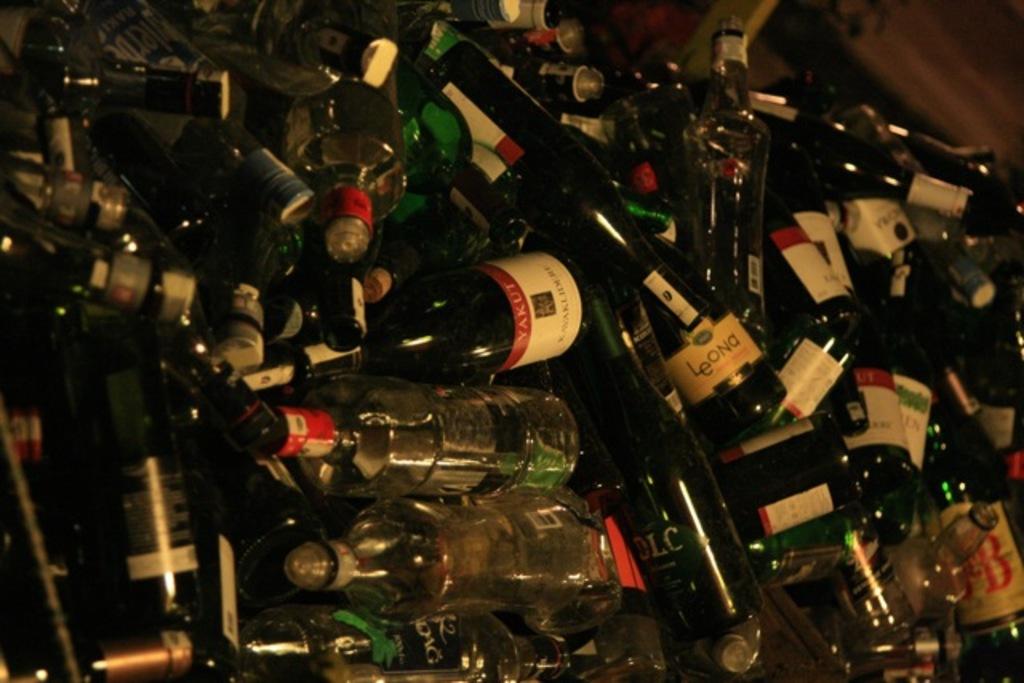Is that a bottle of leona in that pile?
Give a very brief answer. Yes. What does the bottle with the green label say?
Ensure brevity in your answer.  Dlc. 